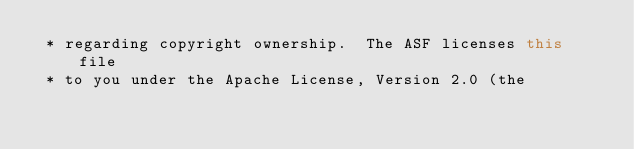<code> <loc_0><loc_0><loc_500><loc_500><_Kotlin_> * regarding copyright ownership.  The ASF licenses this file
 * to you under the Apache License, Version 2.0 (the</code> 